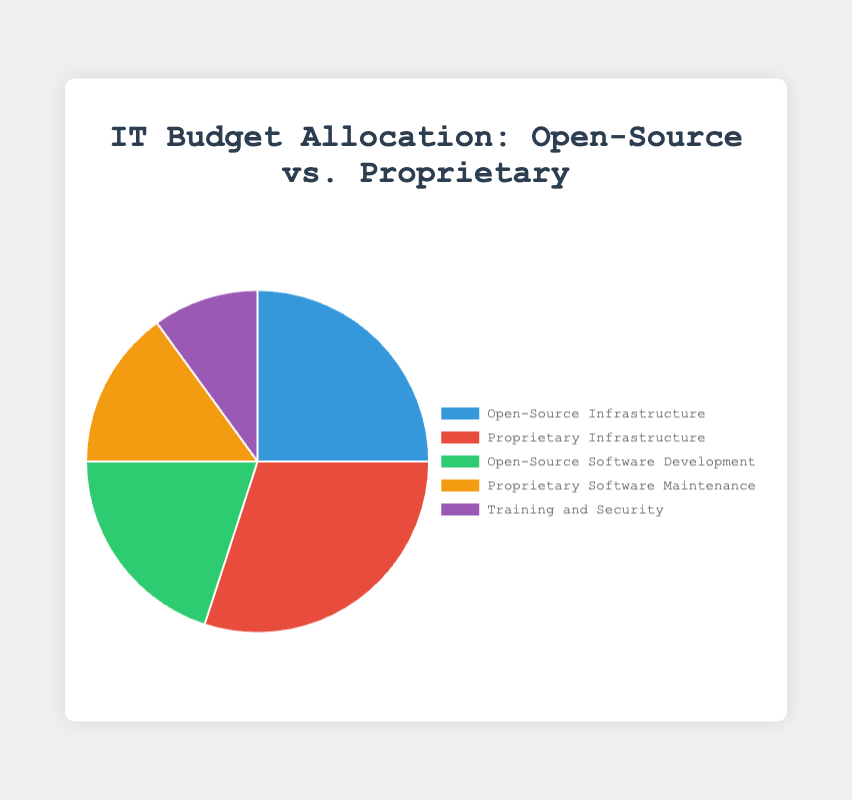What is the largest portion of the IT budget allocated to? By examining the pie chart, we see that the largest portion is in "Proprietary Infrastructure," which takes up 30% of the budget.
Answer: Proprietary Infrastructure Which category has a higher allocation: Open-Source Infrastructure or Open-Source Software Development? The pie chart shows Open-Source Infrastructure at 25% and Open-Source Software Development at 20%, so Open-Source Infrastructure is higher.
Answer: Open-Source Infrastructure What is the combined budget allocation for Open-Source components (Infrastructure and Software Development)? By adding the percentages of Open-Source Infrastructure (25%) and Open-Source Software Development (20%), we get a total of 45%.
Answer: 45% How does the budget allocation for Proprietary Software Maintenance compare to Training and Security? Proprietary Software Maintenance allocation is 15% while Training and Security is 10%. Therefore, Proprietary Software Maintenance has a higher allocation.
Answer: Proprietary Software Maintenance What is the total budget percentage allocated to proprietary solutions (Infrastructure and Software Maintenance)? Adding Proprietary Infrastructure (30%) and Proprietary Software Maintenance (15%) results in a total of 45%.
Answer: 45% Which category is allocated the least amount of the IT budget? Training and Security stands out as the smallest segment in the pie chart, representing 10% of the budget.
Answer: Training and Security Considering all categories, what is the average budget allocation percentage? Summing all the percentages (25% + 30% + 20% + 15% + 10%) gives us 100%. Dividing this by the number of categories, 5, results in an average of 20%.
Answer: 20% Is the budget allocation for Proprietary Infrastructure greater than the combined allocation for Open-Source Software Development and Training and Security? The allocation for Proprietary Infrastructure is 30%, while the combined allocation for Open-Source Software Development (20%) and Training and Security (10%) is also 30%. Therefore, they are equal.
Answer: No, they are equal 